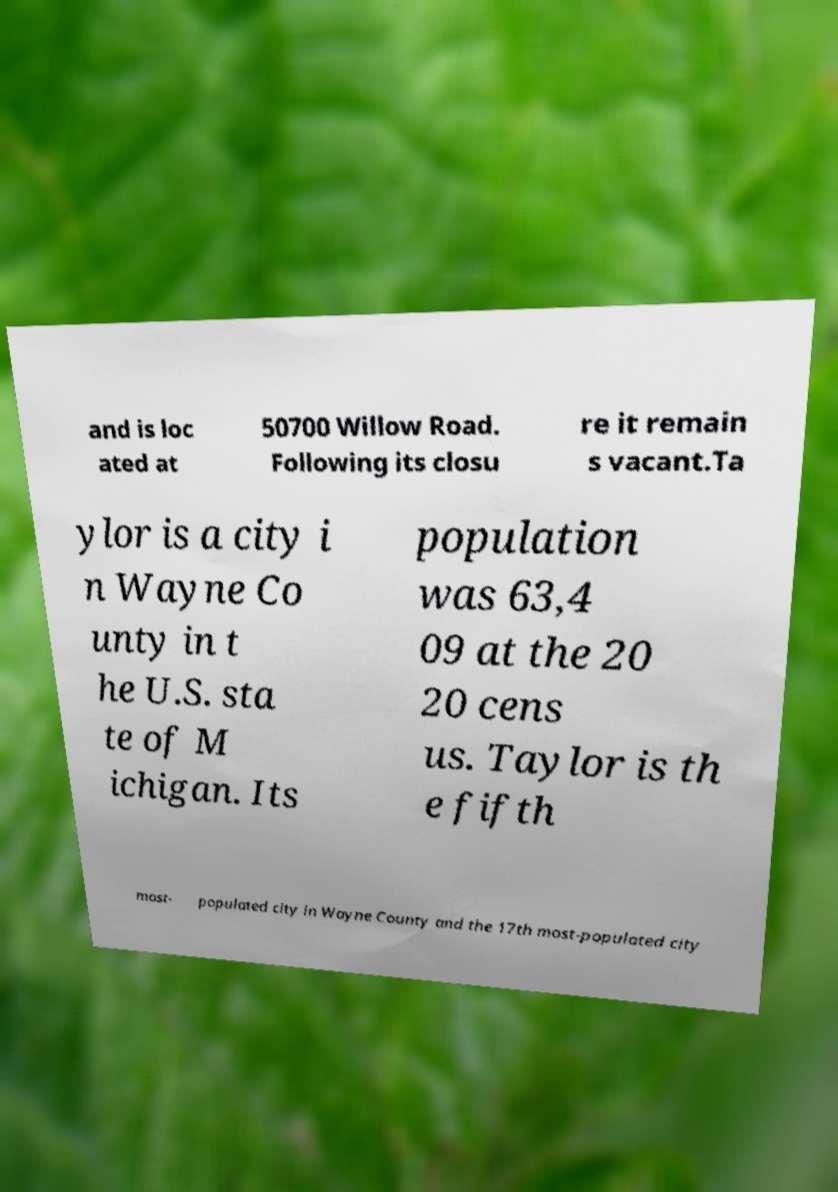For documentation purposes, I need the text within this image transcribed. Could you provide that? and is loc ated at 50700 Willow Road. Following its closu re it remain s vacant.Ta ylor is a city i n Wayne Co unty in t he U.S. sta te of M ichigan. Its population was 63,4 09 at the 20 20 cens us. Taylor is th e fifth most- populated city in Wayne County and the 17th most-populated city 